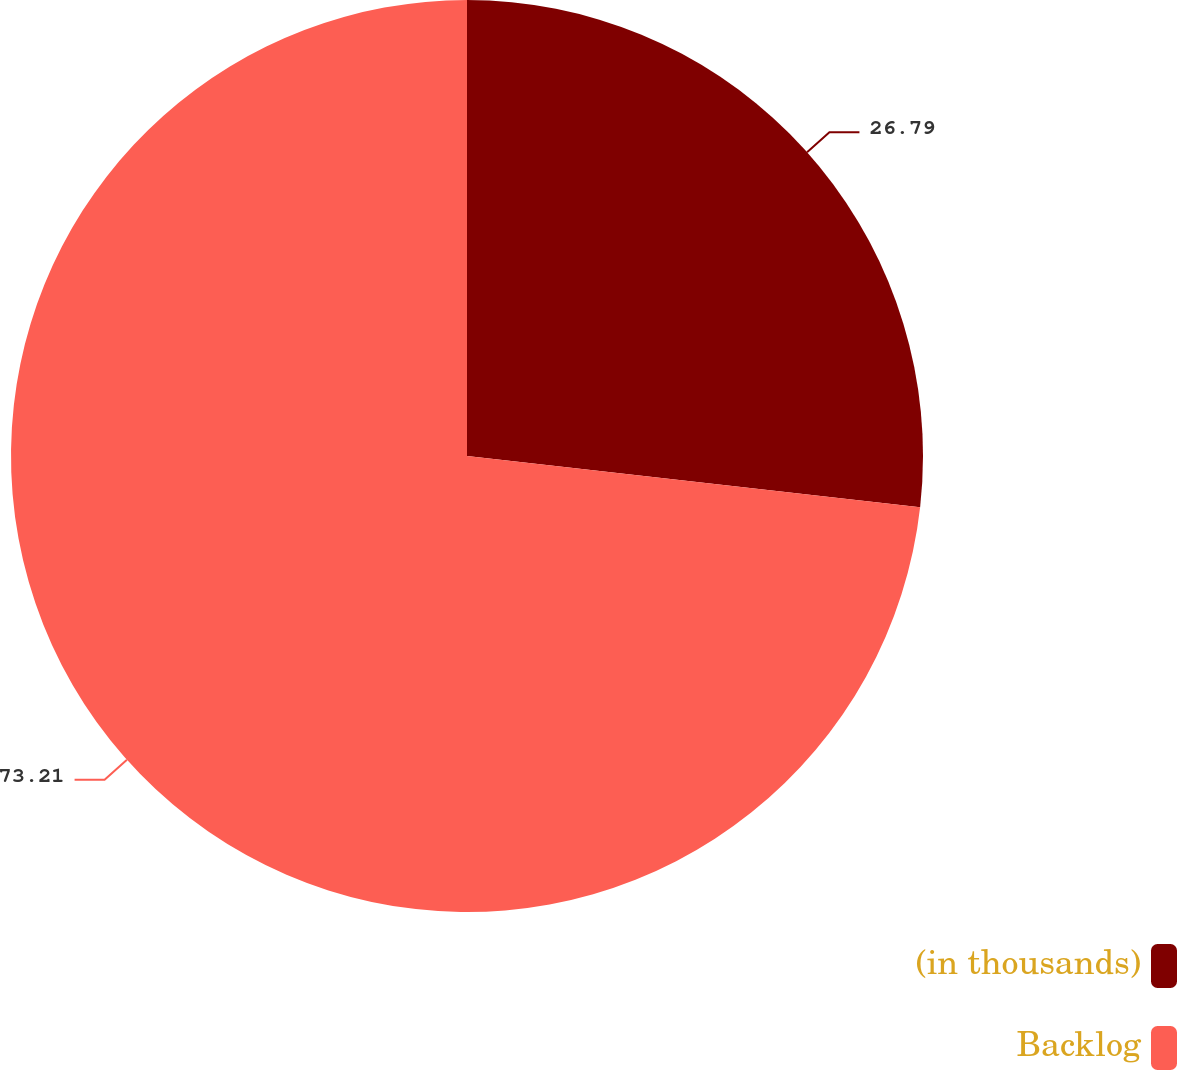<chart> <loc_0><loc_0><loc_500><loc_500><pie_chart><fcel>(in thousands)<fcel>Backlog<nl><fcel>26.79%<fcel>73.21%<nl></chart> 